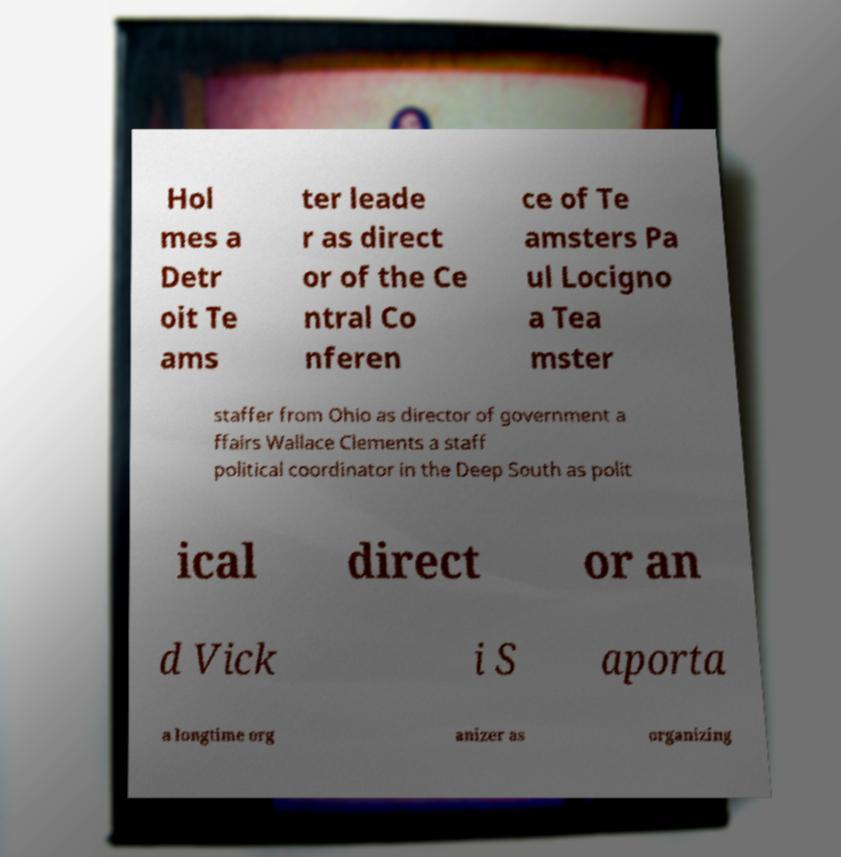What messages or text are displayed in this image? I need them in a readable, typed format. Hol mes a Detr oit Te ams ter leade r as direct or of the Ce ntral Co nferen ce of Te amsters Pa ul Locigno a Tea mster staffer from Ohio as director of government a ffairs Wallace Clements a staff political coordinator in the Deep South as polit ical direct or an d Vick i S aporta a longtime org anizer as organizing 